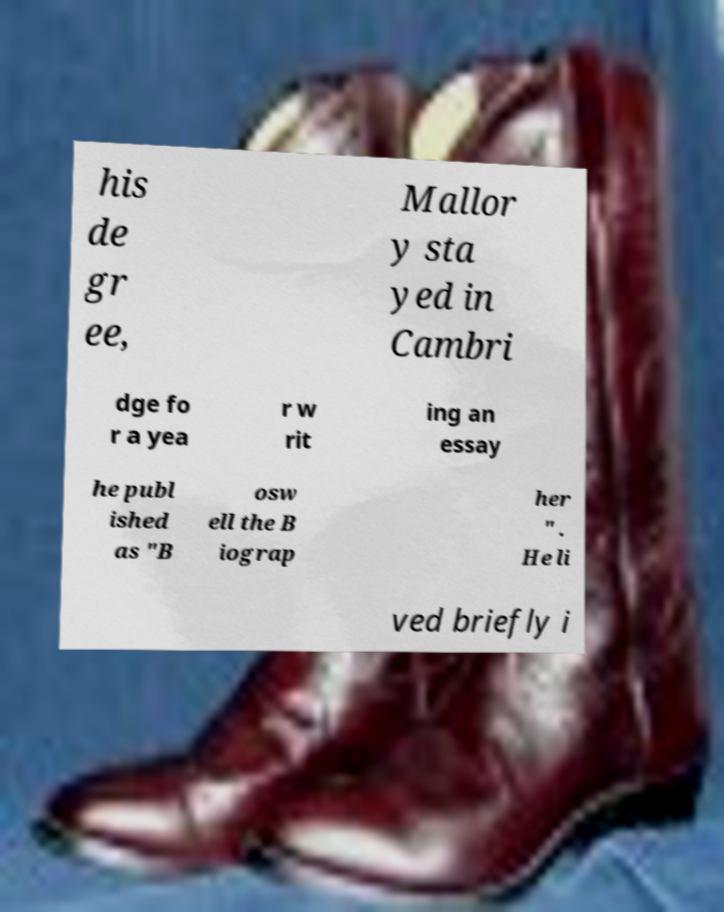For documentation purposes, I need the text within this image transcribed. Could you provide that? his de gr ee, Mallor y sta yed in Cambri dge fo r a yea r w rit ing an essay he publ ished as "B osw ell the B iograp her " . He li ved briefly i 